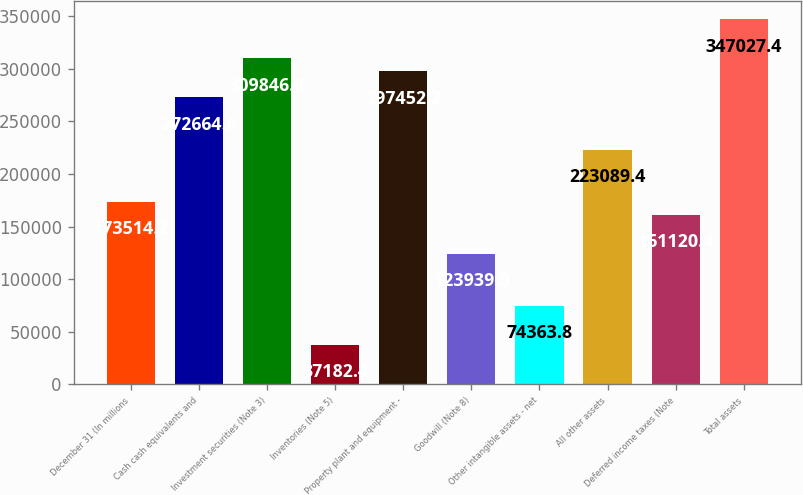Convert chart to OTSL. <chart><loc_0><loc_0><loc_500><loc_500><bar_chart><fcel>December 31 (In millions<fcel>Cash cash equivalents and<fcel>Investment securities (Note 3)<fcel>Inventories (Note 5)<fcel>Property plant and equipment -<fcel>Goodwill (Note 8)<fcel>Other intangible assets - net<fcel>All other assets<fcel>Deferred income taxes (Note<fcel>Total assets<nl><fcel>173514<fcel>272665<fcel>309846<fcel>37182.4<fcel>297452<fcel>123939<fcel>74363.8<fcel>223089<fcel>161120<fcel>347027<nl></chart> 